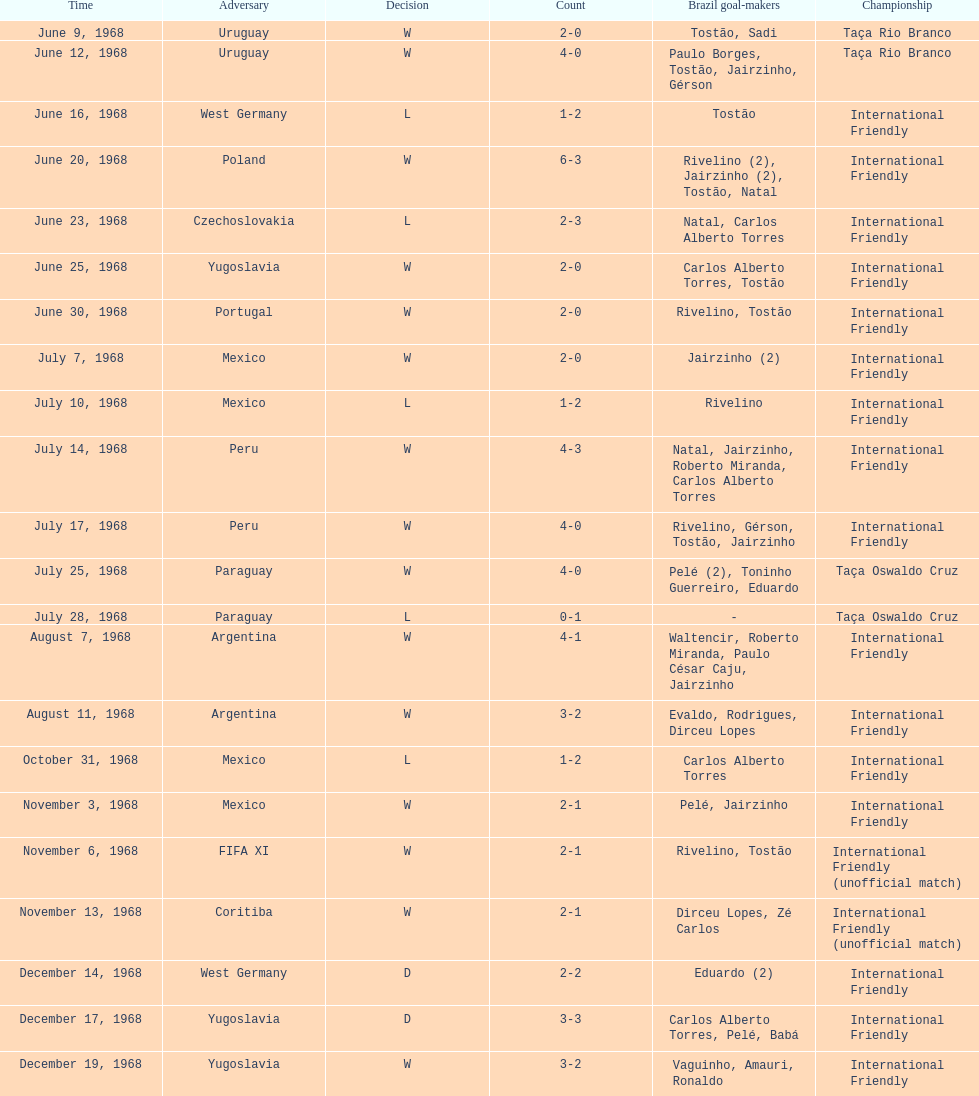Who played brazil previous to the game on june 30th? Yugoslavia. 